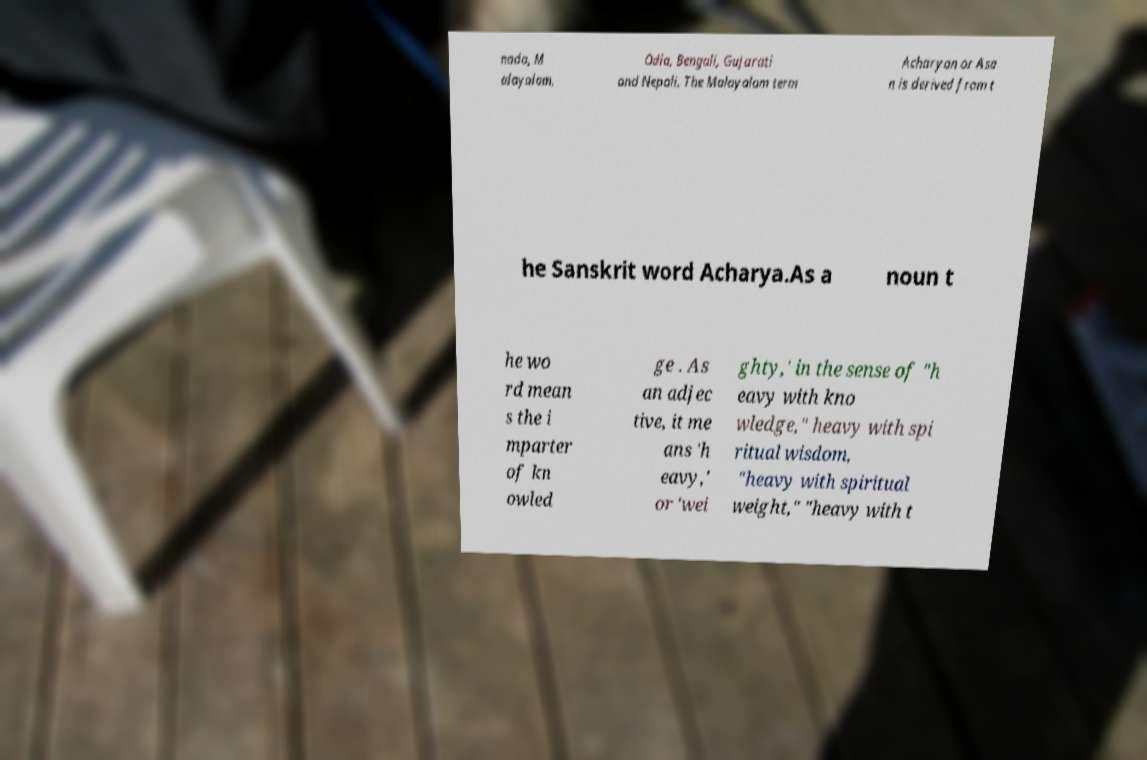Can you read and provide the text displayed in the image?This photo seems to have some interesting text. Can you extract and type it out for me? nada, M alayalam, Odia, Bengali, Gujarati and Nepali. The Malayalam term Acharyan or Asa n is derived from t he Sanskrit word Acharya.As a noun t he wo rd mean s the i mparter of kn owled ge . As an adjec tive, it me ans 'h eavy,' or 'wei ghty,' in the sense of "h eavy with kno wledge," heavy with spi ritual wisdom, "heavy with spiritual weight," "heavy with t 